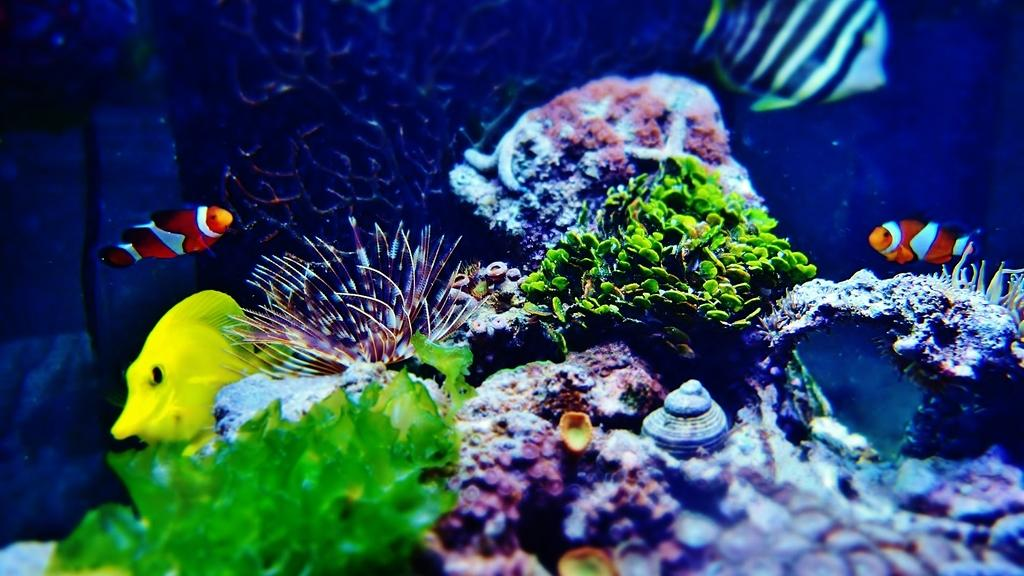What type of animals can be seen in the image? There are fishes in the image. What other elements can be seen in the image besides the fishes? There are shells and coral leaves in the image. Where are all these elements located in the image? All of these elements are underwater. What type of steel structure can be seen in the image? There is no steel structure present in the image; it features underwater elements such as fishes, shells, and coral leaves. What is the purpose of the drain in the image? There is no drain present in the image. 